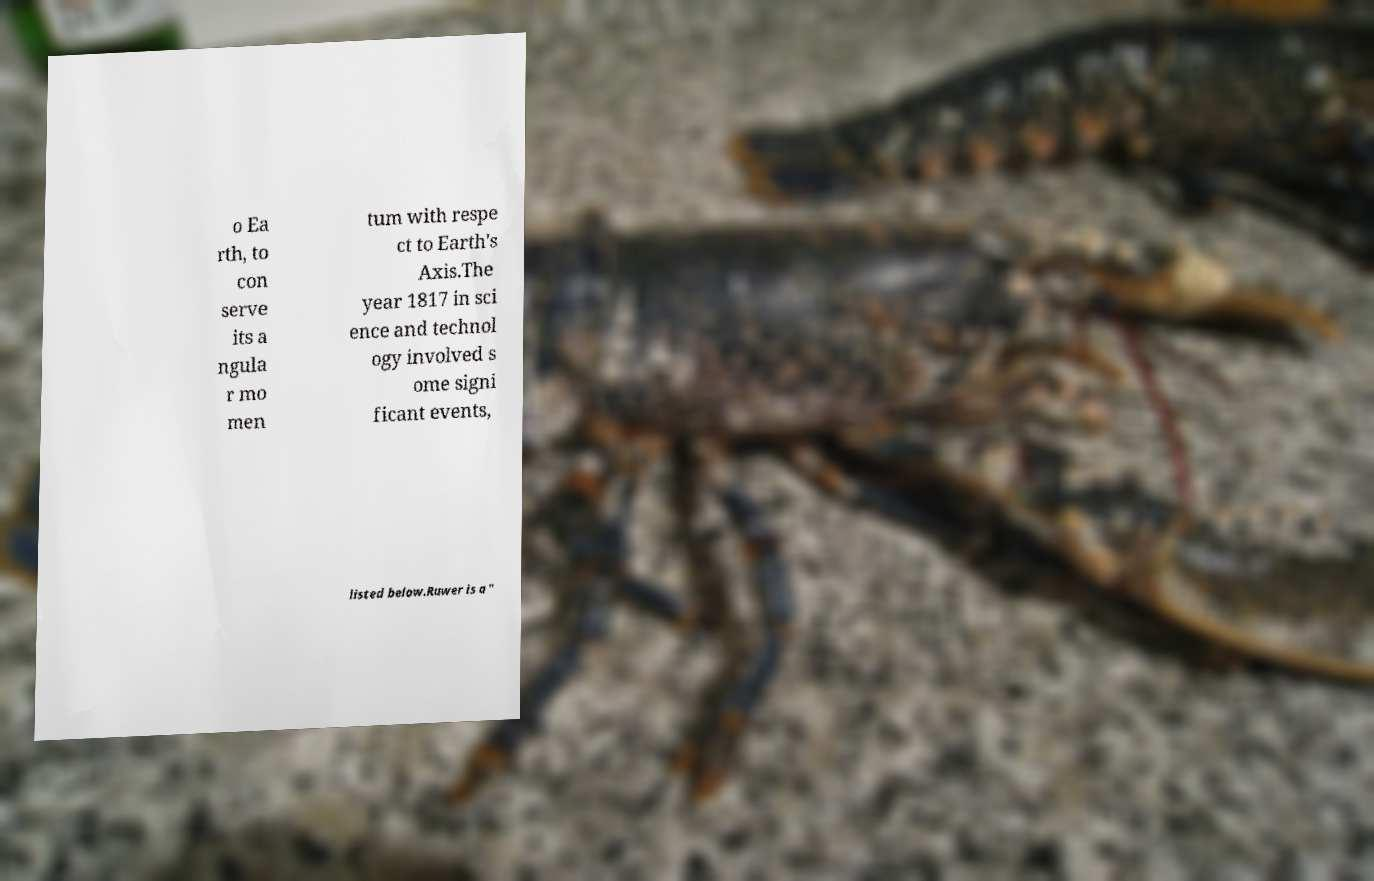Please read and relay the text visible in this image. What does it say? o Ea rth, to con serve its a ngula r mo men tum with respe ct to Earth's Axis.The year 1817 in sci ence and technol ogy involved s ome signi ficant events, listed below.Ruwer is a " 